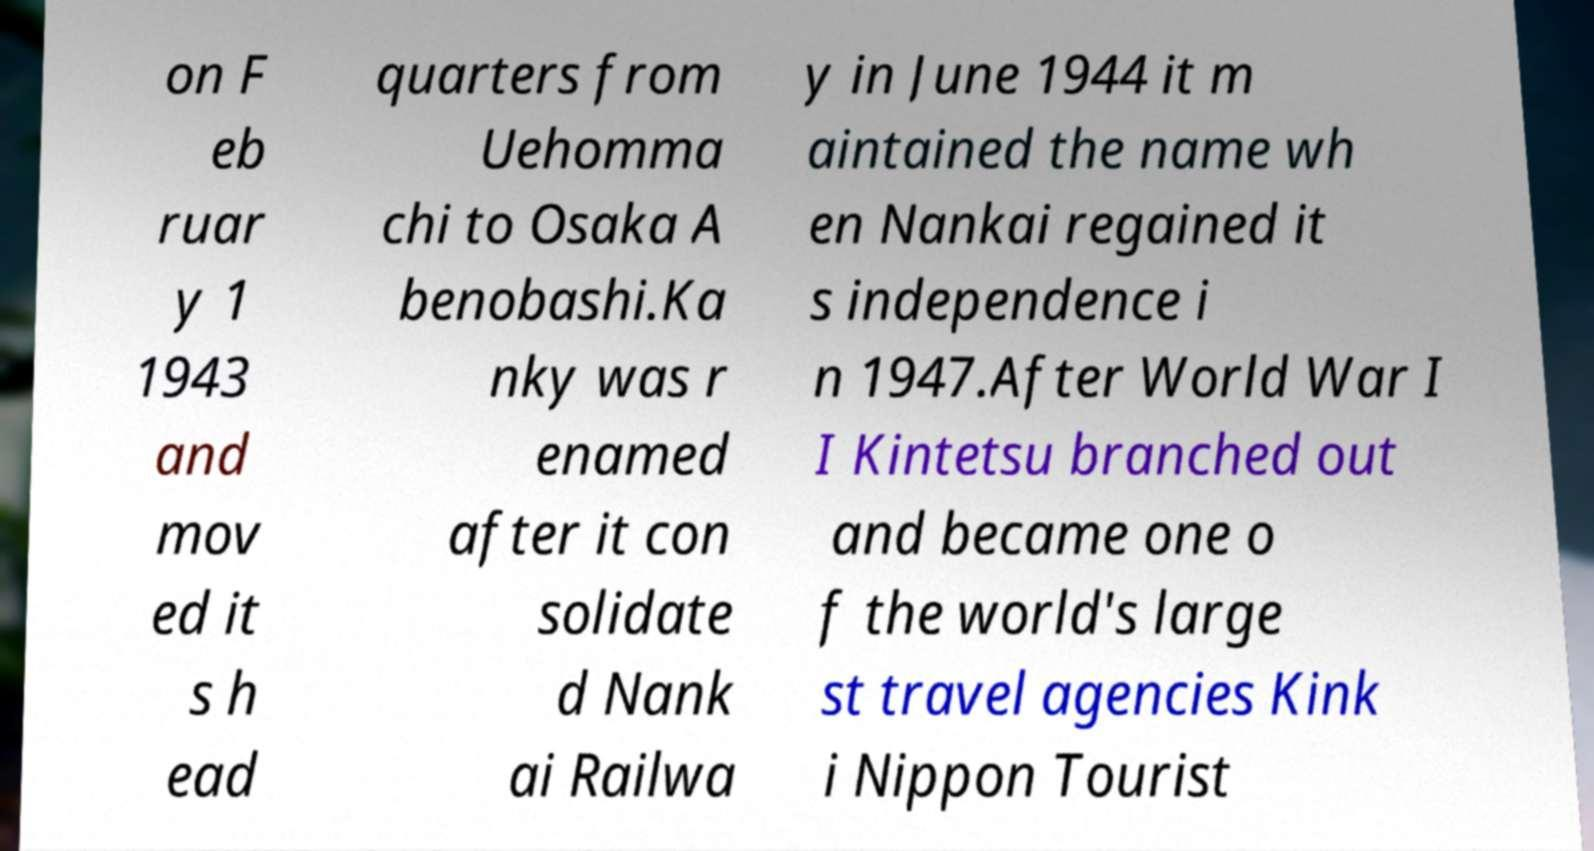For documentation purposes, I need the text within this image transcribed. Could you provide that? on F eb ruar y 1 1943 and mov ed it s h ead quarters from Uehomma chi to Osaka A benobashi.Ka nky was r enamed after it con solidate d Nank ai Railwa y in June 1944 it m aintained the name wh en Nankai regained it s independence i n 1947.After World War I I Kintetsu branched out and became one o f the world's large st travel agencies Kink i Nippon Tourist 